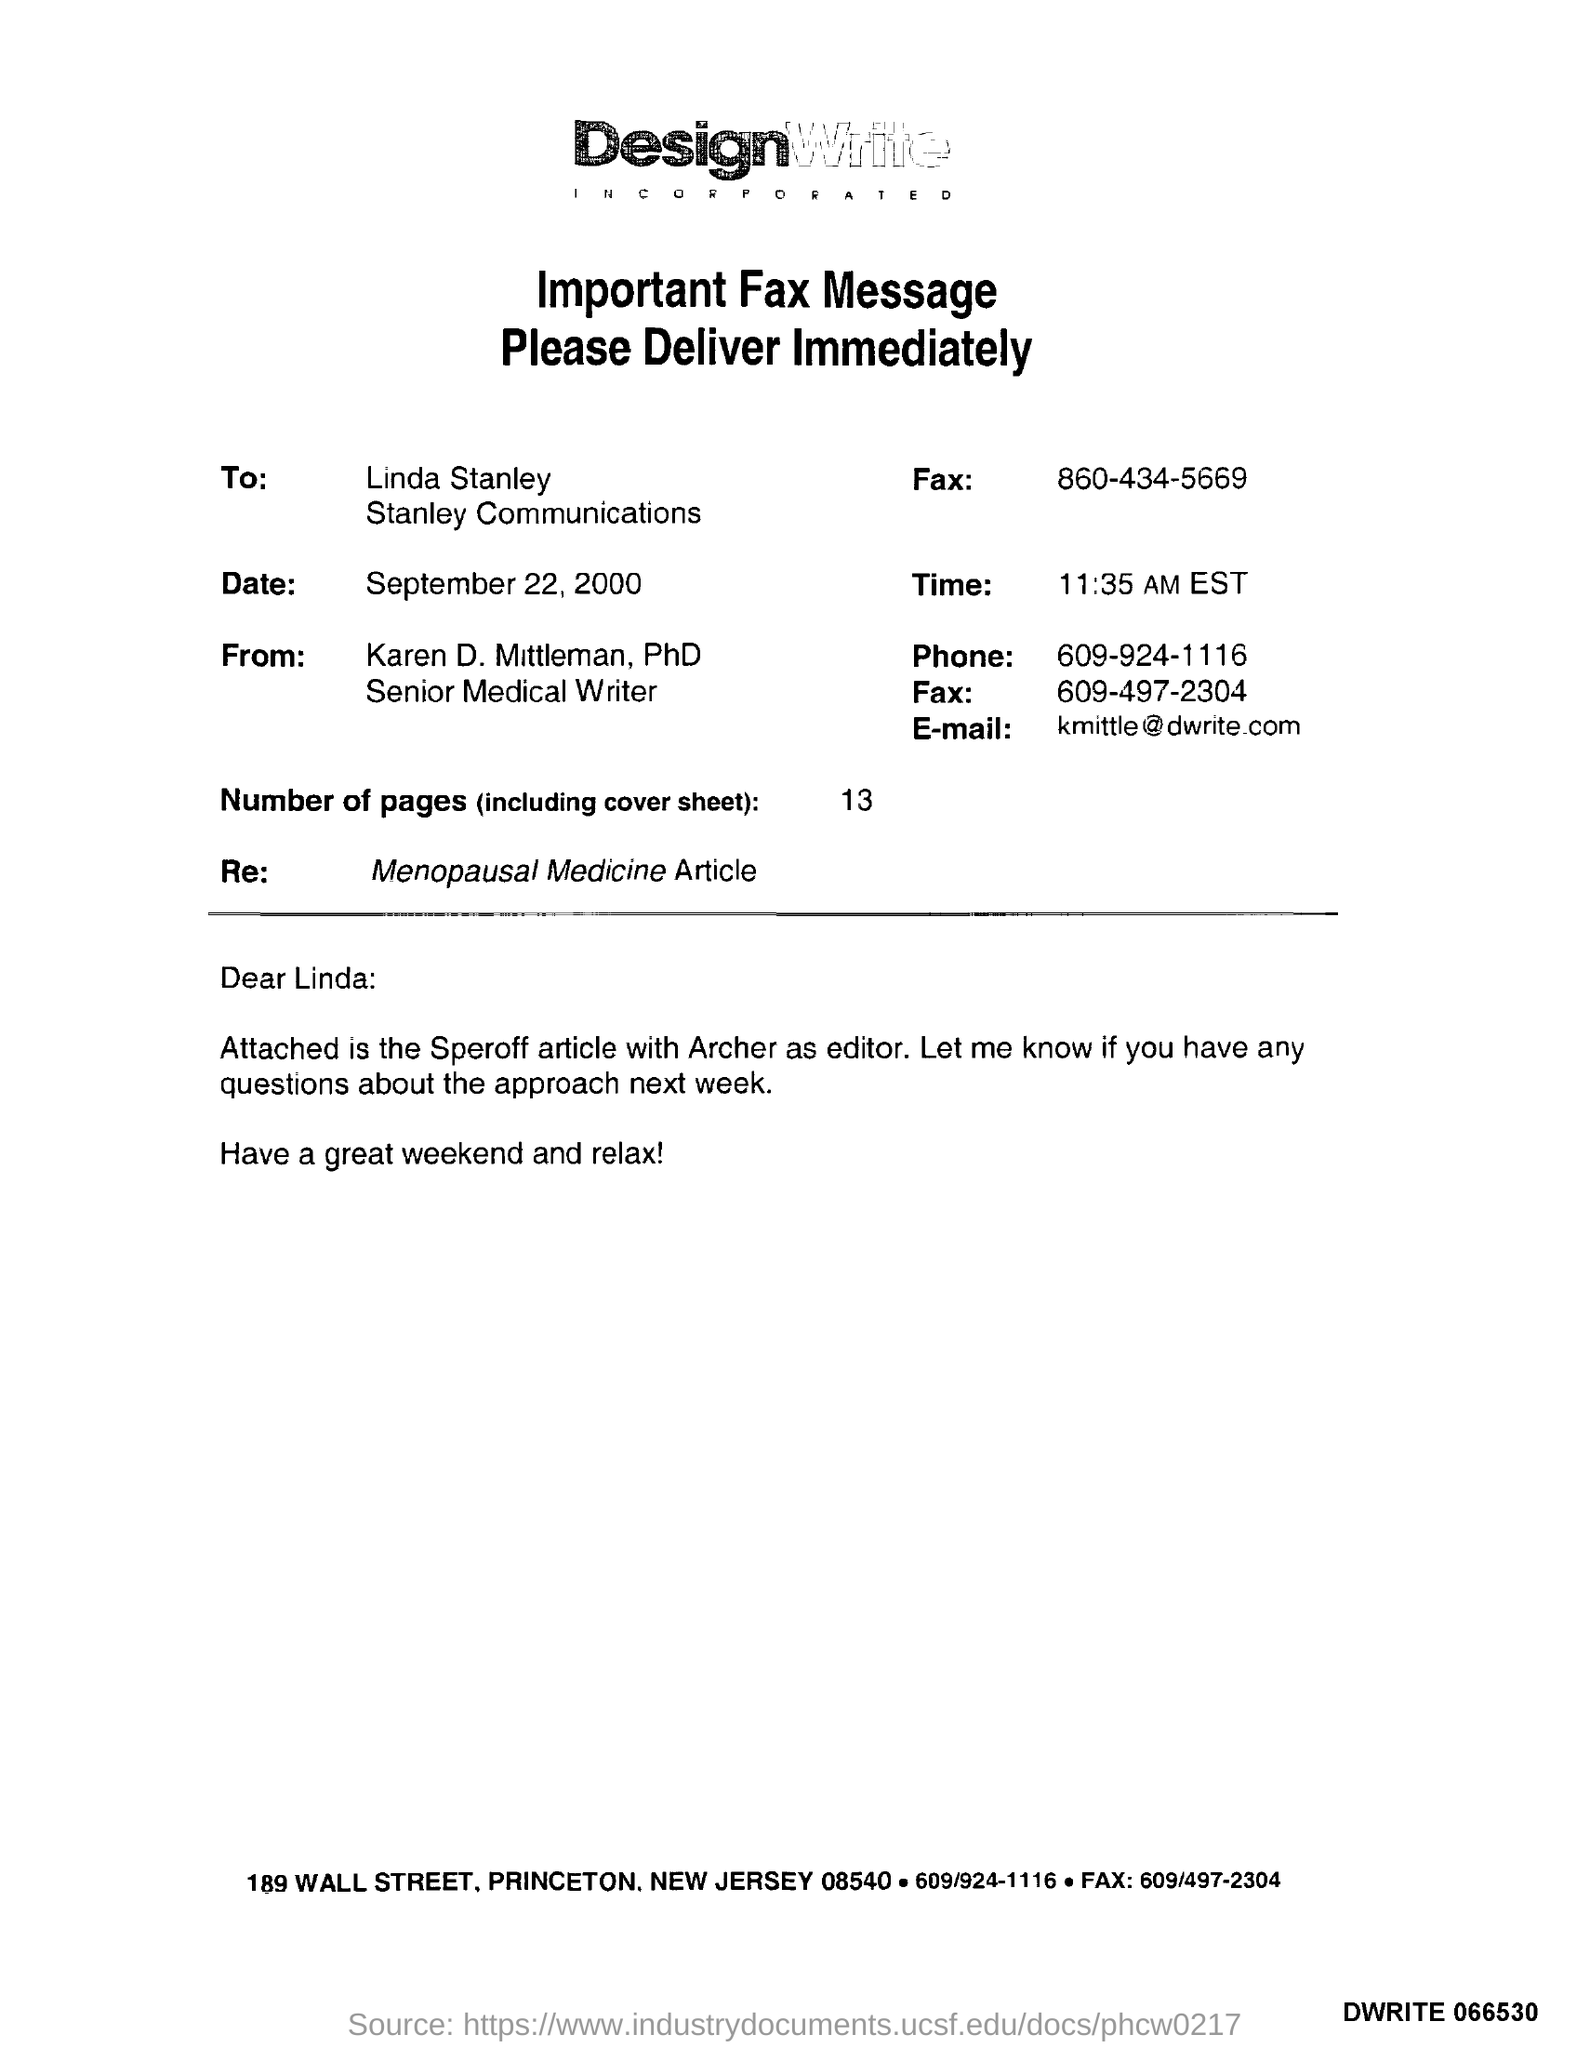Identify some key points in this picture. The memorandum is from Karen D. Mittleman. The sender's fax number is 609-497-2304. There are 13 pages in this sheet. The memorandum is addressed to Linda Stanley. The content written in the "Re" field corresponds to an article published in Menopausal Medicine. 